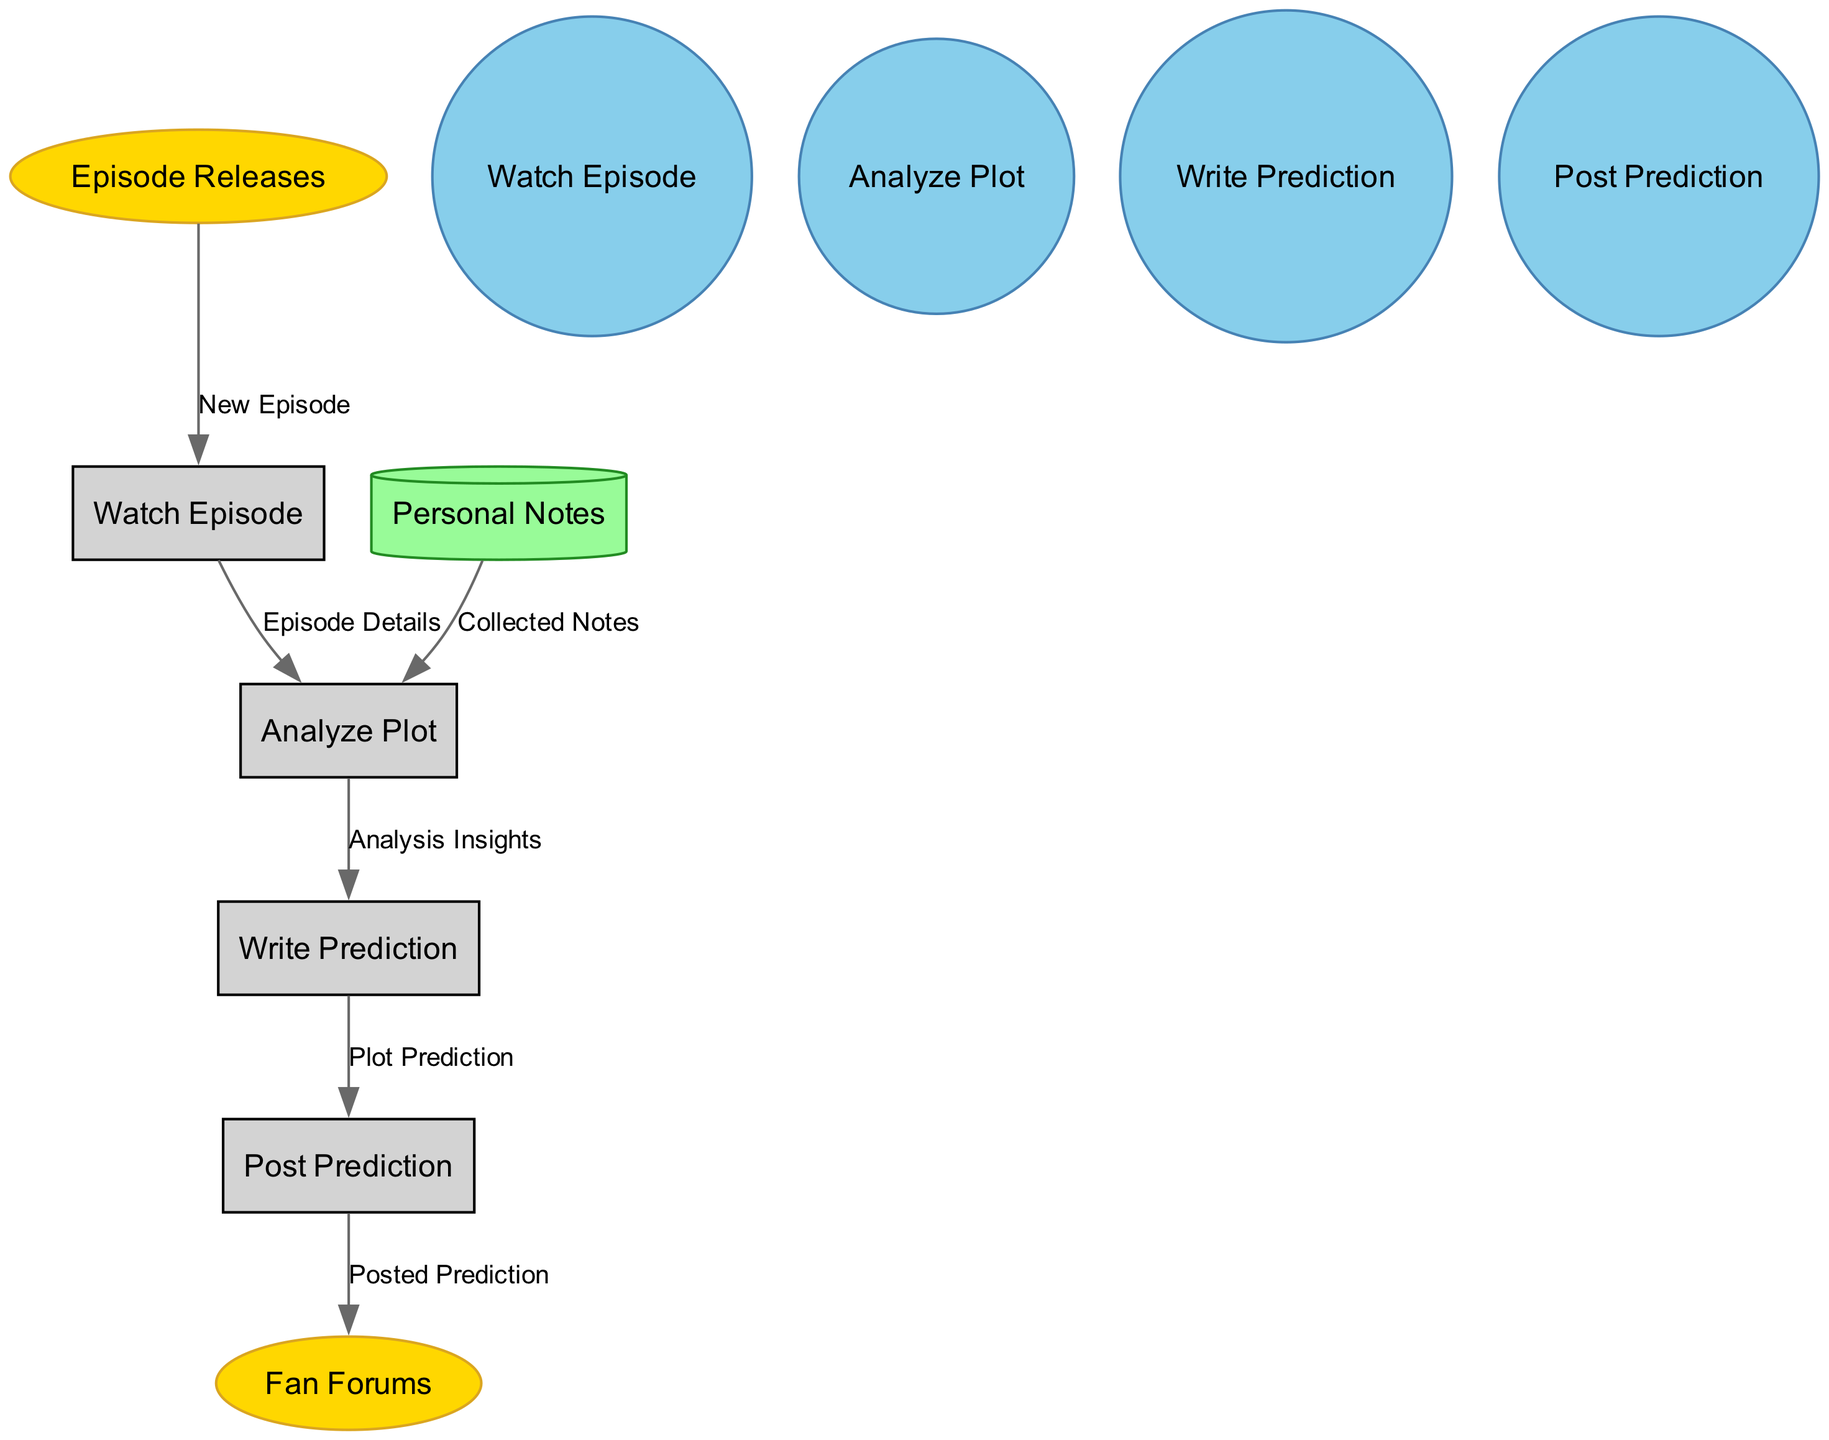What are the external entities in the diagram? The external entities listed in the diagram include "Episode Releases" and "Fan Forums." These entities represent sources and platforms relevant to the viewing and discussion of "Poker Face."
Answer: Episode Releases, Fan Forums How many processes are represented in the diagram? The diagram features four processes: "Watch Episode," "Analyze Plot," "Write Prediction," and "Post Prediction." Counting these processes gives a total of four.
Answer: 4 What is the purpose of the "Personal Notes" data store? The "Personal Notes" data store serves to hold the viewer's notes collected during the episode watching and analysis stages, which can later inform predictions.
Answer: Viewer notes Which process directly follows "Analyze Plot"? Following the "Analyze Plot" process, the next step is "Write Prediction," where the viewer formulates their plot predictions based on their analysis.
Answer: Write Prediction What data flow is connected to "Post Prediction"? The "Post Prediction" process has a data flow labeled "Posted Prediction" that indicates the prediction written by the viewer is shared on fan forums.
Answer: Posted Prediction How does the viewer receive new episodes? The viewer receives new episodes through the "Episode Releases," which serves as an external entity supplying fresh content for analysis and predictions.
Answer: Episode Releases What data is used in the "Analyze Plot" process? The "Analyze Plot" process utilizes data from two sources: "Episode Details" derived from the "Watch Episode" process, and "Collected Notes" from the "Personal Notes" store, which combines insights and viewer observations.
Answer: Episode Details, Collected Notes Which node initiates the overall flow of the diagram? The flow in the diagram begins with the "Episode Releases" external entity, as it is the starting point for the viewer to engage with new content.
Answer: Episode Releases What is the last step in the prediction process? The last step in the prediction process is "Post Prediction," where the viewer shares their written predictions on fan forums, completing the cycle of analysis and sharing.
Answer: Post Prediction 